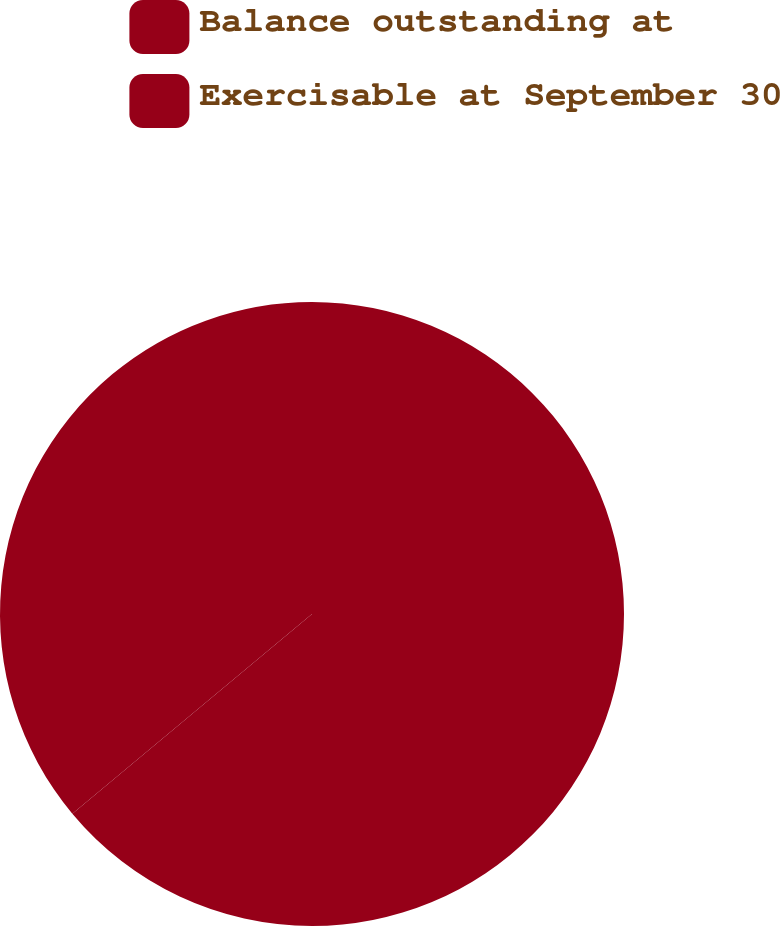Convert chart. <chart><loc_0><loc_0><loc_500><loc_500><pie_chart><fcel>Balance outstanding at<fcel>Exercisable at September 30<nl><fcel>63.94%<fcel>36.06%<nl></chart> 